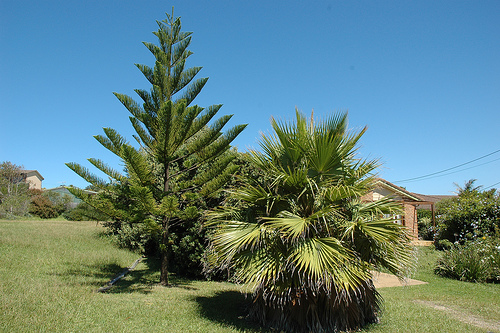<image>
Is there a sky behind the house? Yes. From this viewpoint, the sky is positioned behind the house, with the house partially or fully occluding the sky. 